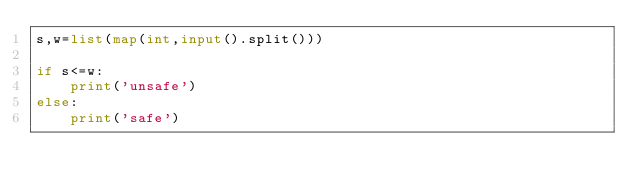<code> <loc_0><loc_0><loc_500><loc_500><_Python_>s,w=list(map(int,input().split()))

if s<=w:
    print('unsafe')
else:
    print('safe')</code> 